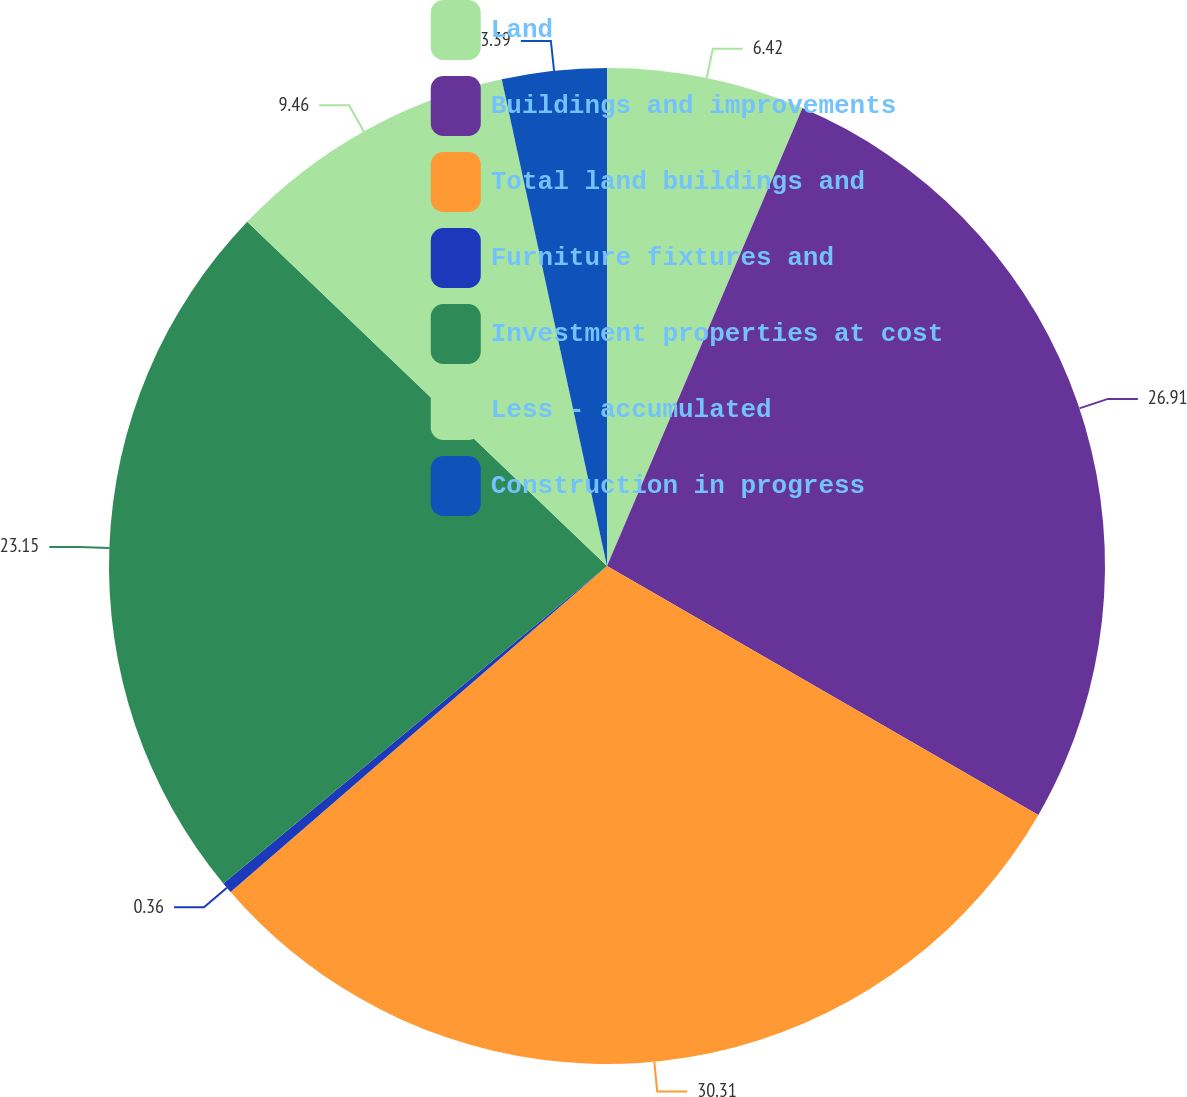Convert chart. <chart><loc_0><loc_0><loc_500><loc_500><pie_chart><fcel>Land<fcel>Buildings and improvements<fcel>Total land buildings and<fcel>Furniture fixtures and<fcel>Investment properties at cost<fcel>Less - accumulated<fcel>Construction in progress<nl><fcel>6.42%<fcel>26.91%<fcel>30.31%<fcel>0.36%<fcel>23.15%<fcel>9.46%<fcel>3.39%<nl></chart> 